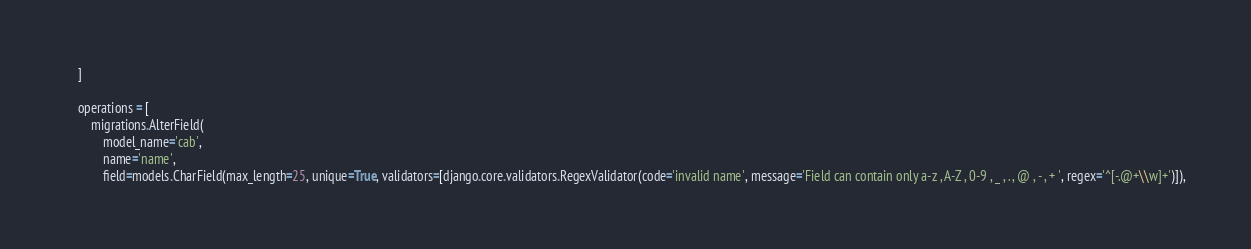Convert code to text. <code><loc_0><loc_0><loc_500><loc_500><_Python_>    ]

    operations = [
        migrations.AlterField(
            model_name='cab',
            name='name',
            field=models.CharField(max_length=25, unique=True, validators=[django.core.validators.RegexValidator(code='invalid name', message='Field can contain only a-z , A-Z , 0-9 , _ , . , @ , - , + ', regex='^[-.@+\\w]+')]),</code> 